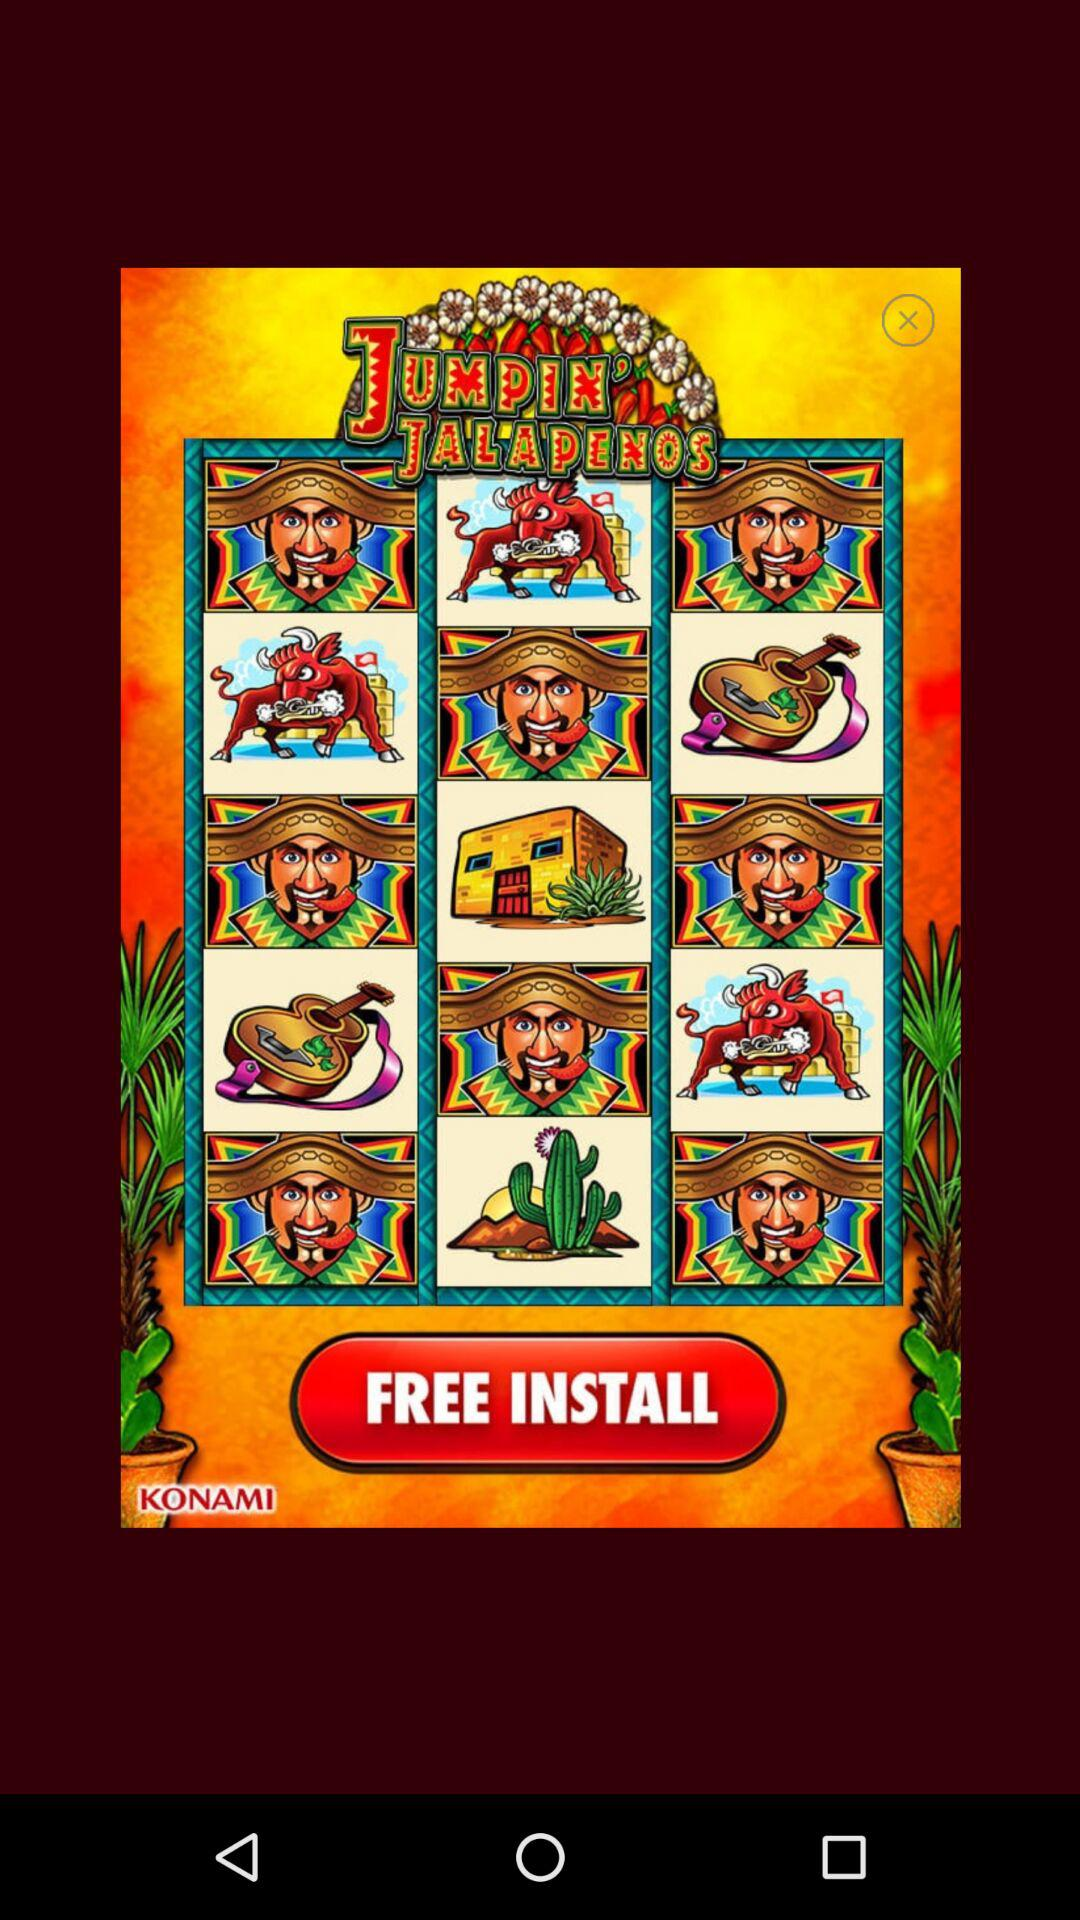What is the application name? The application name is "JUMPIN' JALAPENOS". 